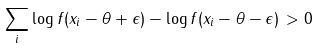Convert formula to latex. <formula><loc_0><loc_0><loc_500><loc_500>\sum _ { i } \log f ( x _ { i } - \theta + \epsilon ) - \log f ( x _ { i } - \theta - \epsilon ) \, > 0</formula> 